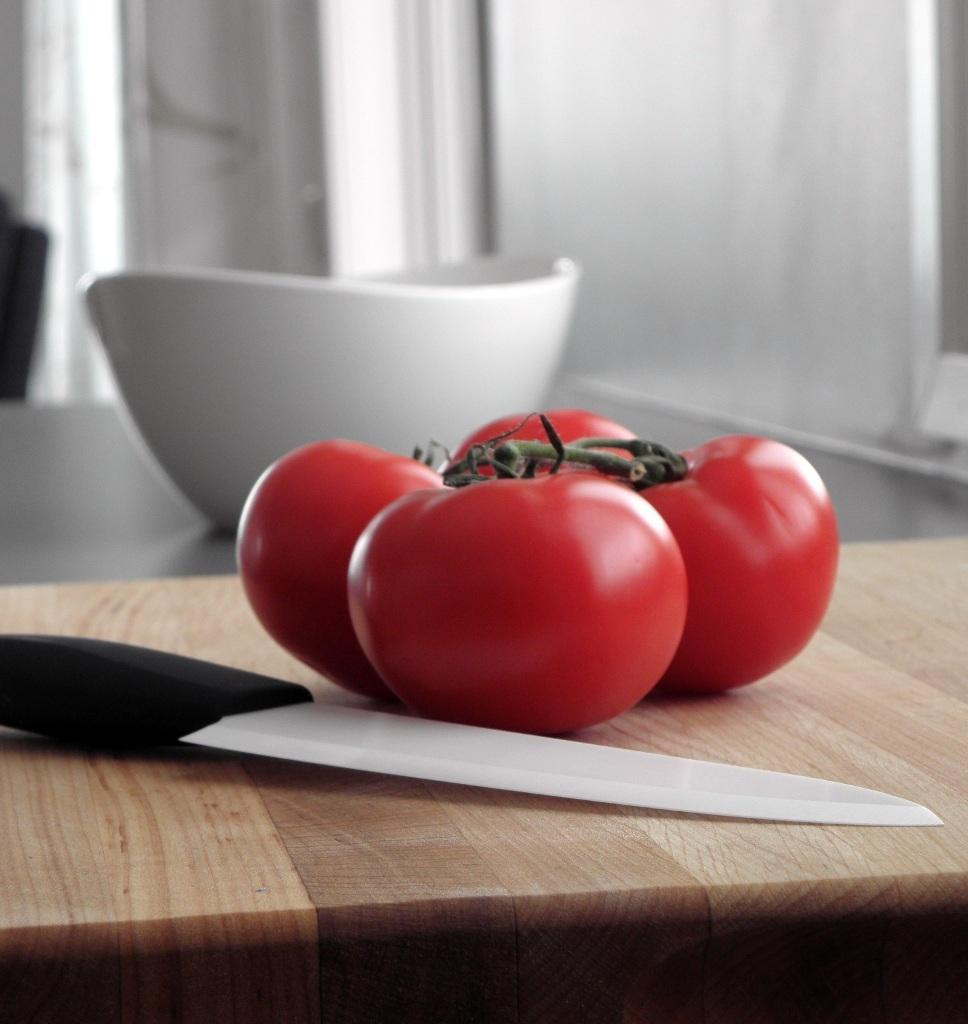What type of fruit is present in the image? There are red tomatoes in the image. What utensil can be seen in the image? There is a knife in the image. What container is visible in the image? There is a bowl in the image. Where are the red tomatoes, knife, and bowl located in the image? The red tomatoes, knife, and bowl are placed on a table. What type of smile can be seen on the tomatoes in the image? Tomatoes do not have the ability to smile, as they are inanimate objects. What type of brick is visible in the image? There is no brick present in the image. 